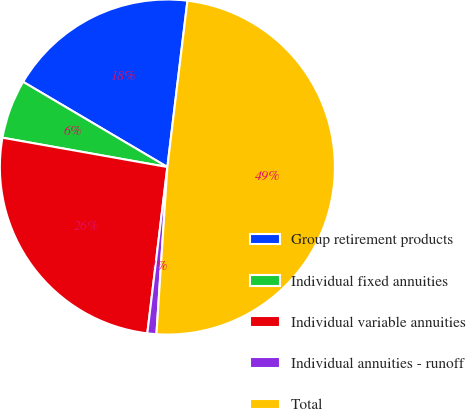<chart> <loc_0><loc_0><loc_500><loc_500><pie_chart><fcel>Group retirement products<fcel>Individual fixed annuities<fcel>Individual variable annuities<fcel>Individual annuities - runoff<fcel>Total<nl><fcel>18.42%<fcel>5.69%<fcel>25.89%<fcel>0.87%<fcel>49.13%<nl></chart> 